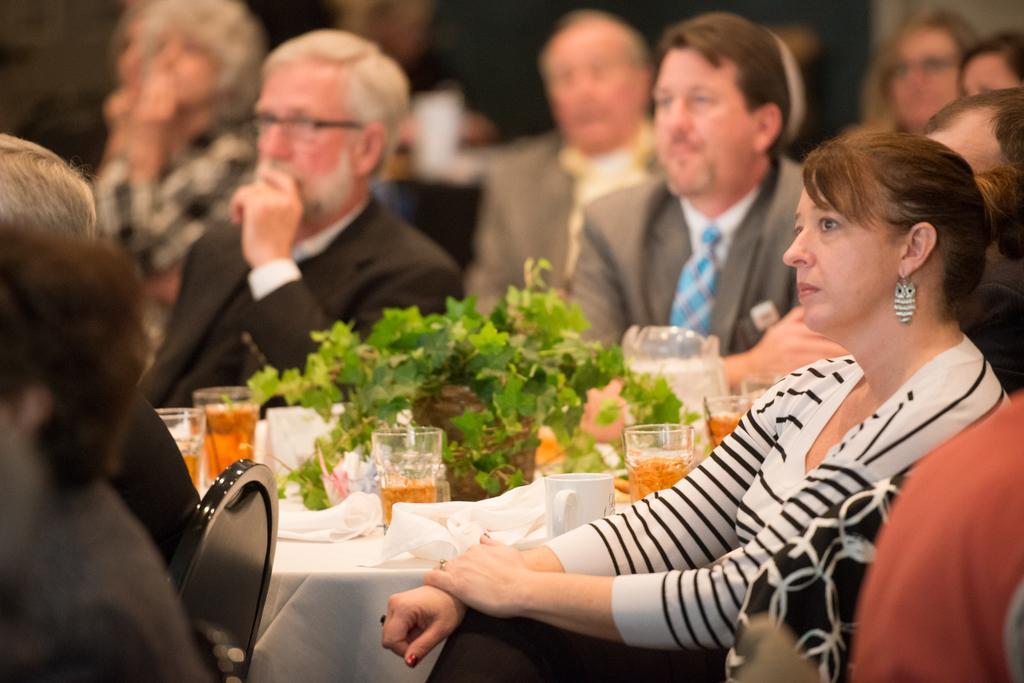How would you summarize this image in a sentence or two? In the foreground of this image, there are people sitting on the chairs around the table on which, there are glasses, a cup, white clothes and a plant. In the background, there are people sitting. 